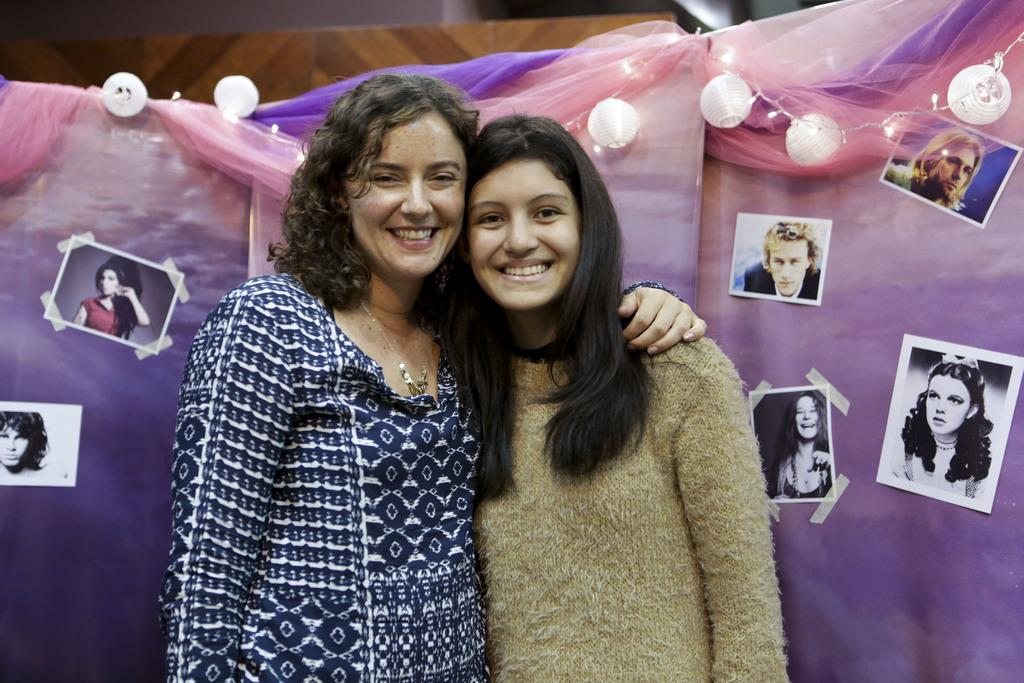How many women are in the image? There are two women in the image. What expression do the women have? The women are smiling. What can be seen in the background of the image? There are lights, photos on a cloth, and other objects visible in the background. How many icicles are hanging from the table in the image? There are no icicles present in the image, as it is indoors and not cold enough for icicles to form. What is the value of the dime on the table in the image? There is no dime present in the image. 